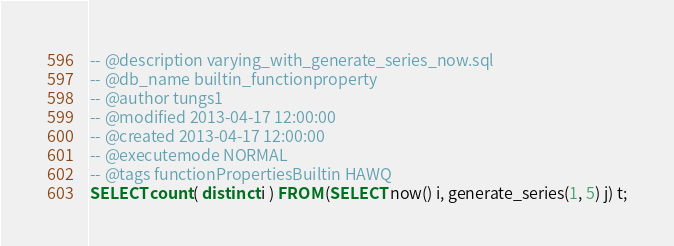<code> <loc_0><loc_0><loc_500><loc_500><_SQL_>-- @description varying_with_generate_series_now.sql
-- @db_name builtin_functionproperty
-- @author tungs1
-- @modified 2013-04-17 12:00:00
-- @created 2013-04-17 12:00:00
-- @executemode NORMAL
-- @tags functionPropertiesBuiltin HAWQ
SELECT count( distinct i ) FROM (SELECT now() i, generate_series(1, 5) j) t;
</code> 